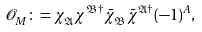<formula> <loc_0><loc_0><loc_500><loc_500>\mathcal { O } ^ { \ } _ { M } \colon = \chi ^ { \ } _ { \mathfrak { A } } \chi ^ { \mathfrak { B } \dag } \bar { \chi } ^ { \ } _ { \mathfrak { B } } \bar { \chi } ^ { \mathfrak { A } \dag } ( - 1 ) ^ { A } ,</formula> 